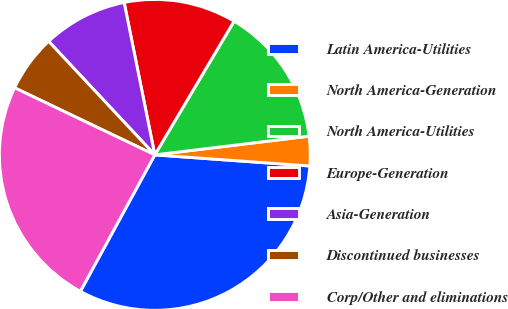Convert chart. <chart><loc_0><loc_0><loc_500><loc_500><pie_chart><fcel>Latin America-Utilities<fcel>North America-Generation<fcel>North America-Utilities<fcel>Europe-Generation<fcel>Asia-Generation<fcel>Discontinued businesses<fcel>Corp/Other and eliminations<nl><fcel>31.81%<fcel>3.06%<fcel>14.56%<fcel>11.68%<fcel>8.81%<fcel>5.93%<fcel>24.16%<nl></chart> 